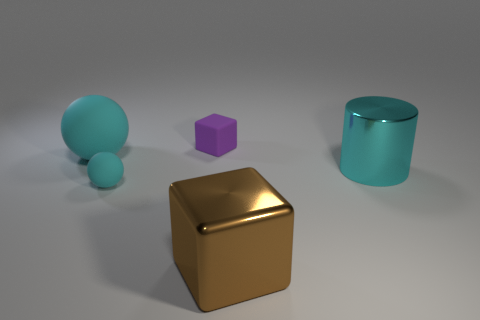There is a metal object that is the same color as the big rubber sphere; what is its size?
Give a very brief answer. Large. There is a large matte thing that is the same color as the large cylinder; what shape is it?
Ensure brevity in your answer.  Sphere. There is a large metal thing that is on the right side of the brown block; does it have the same color as the big metallic cube?
Offer a very short reply. No. There is a cyan thing that is to the right of the purple matte thing; what material is it?
Give a very brief answer. Metal. What is the size of the purple rubber object?
Your answer should be compact. Small. Is the material of the big cyan thing left of the big cyan cylinder the same as the big brown block?
Provide a succinct answer. No. What number of red objects are there?
Provide a short and direct response. 0. What number of things are green rubber blocks or tiny purple matte things?
Your response must be concise. 1. How many large cylinders are to the right of the cyan object to the right of the tiny purple object on the left side of the large cube?
Offer a terse response. 0. Is there any other thing that has the same color as the small rubber sphere?
Ensure brevity in your answer.  Yes. 